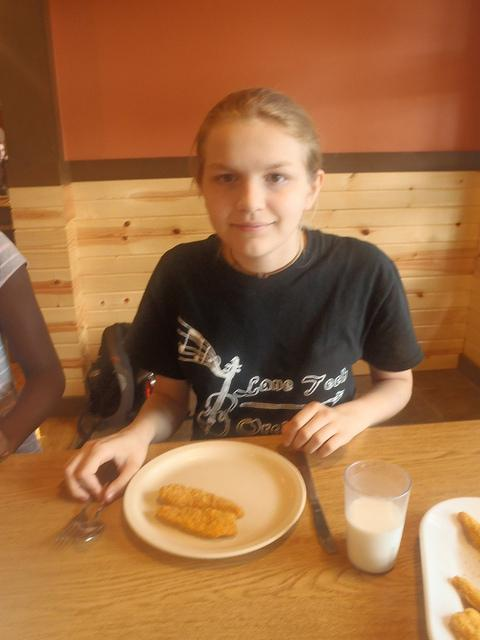What side dish would compliment his food quite well? fries 